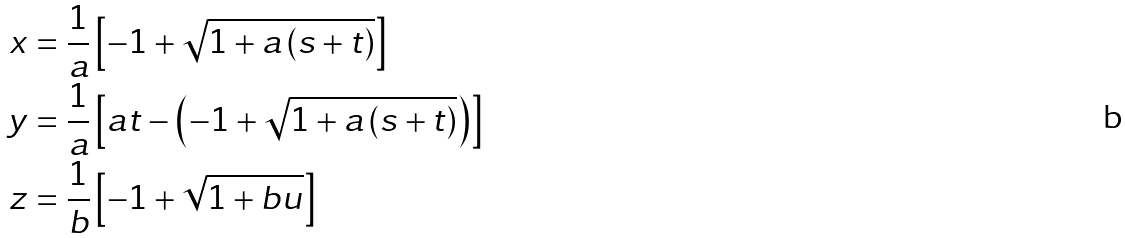<formula> <loc_0><loc_0><loc_500><loc_500>x & = \frac { 1 } { a } \left [ - 1 + \sqrt { 1 + a \left ( s + t \right ) } \right ] \\ y & = \frac { 1 } { a } \left [ a t - \left ( - 1 + \sqrt { 1 + a \left ( s + t \right ) } \right ) \right ] \\ z & = \frac { 1 } { b } \left [ - 1 + \sqrt { 1 + b u } \right ]</formula> 